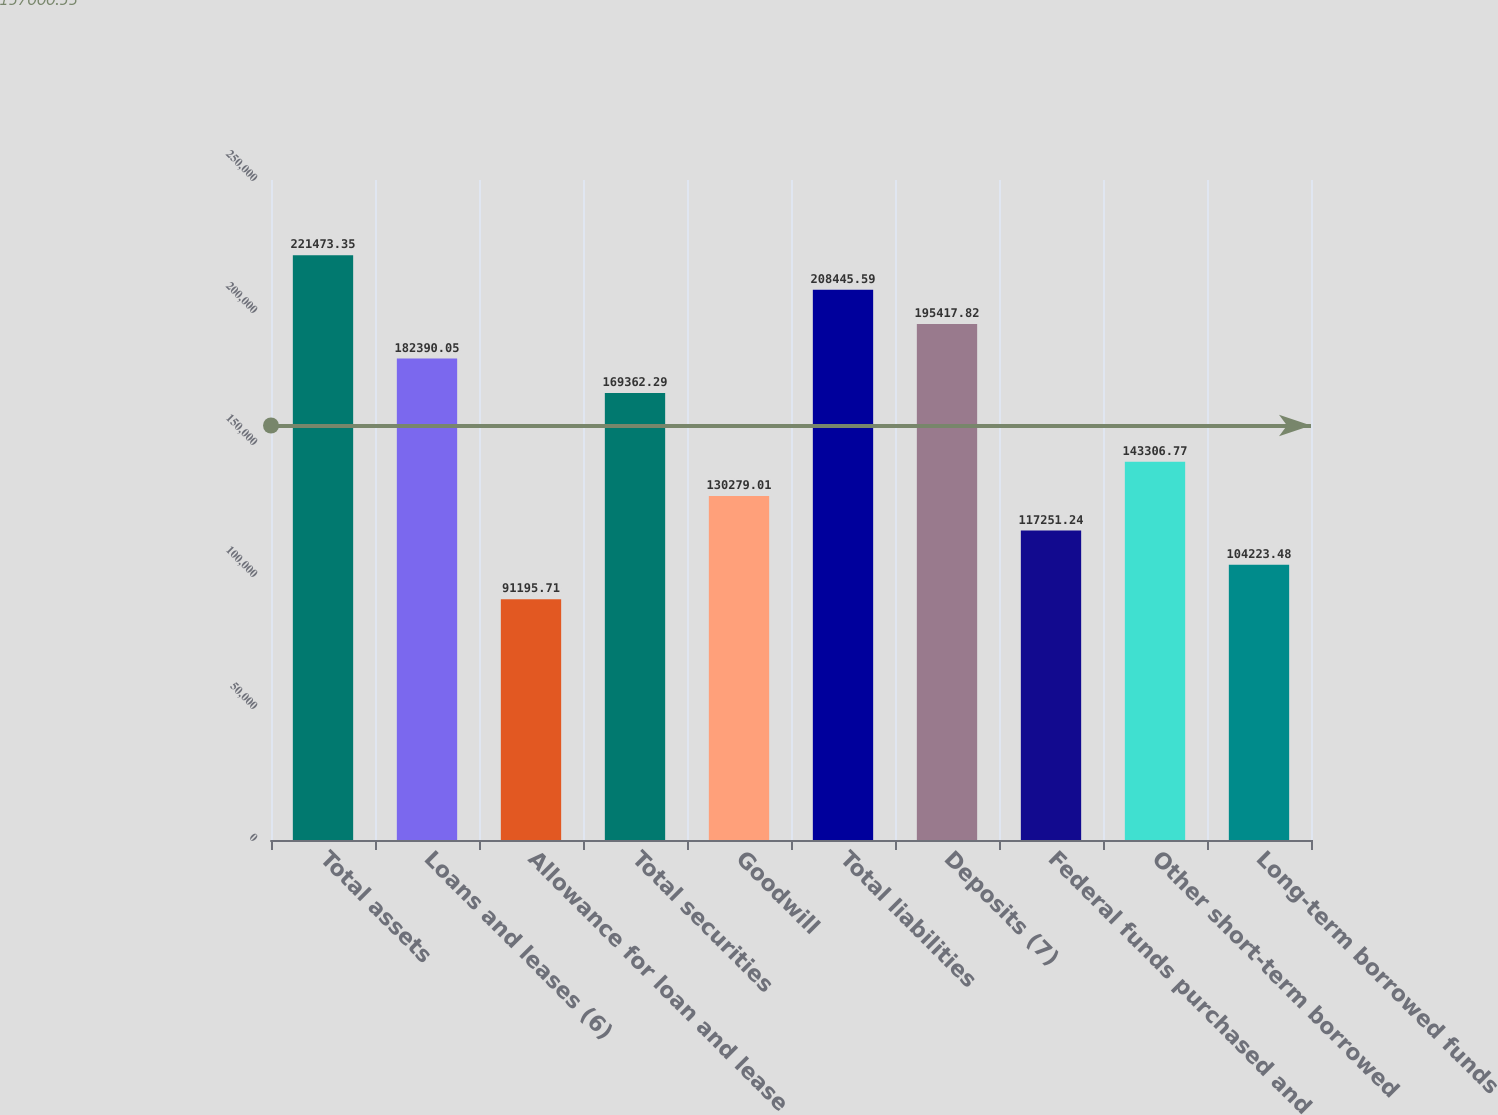<chart> <loc_0><loc_0><loc_500><loc_500><bar_chart><fcel>Total assets<fcel>Loans and leases (6)<fcel>Allowance for loan and lease<fcel>Total securities<fcel>Goodwill<fcel>Total liabilities<fcel>Deposits (7)<fcel>Federal funds purchased and<fcel>Other short-term borrowed<fcel>Long-term borrowed funds<nl><fcel>221473<fcel>182390<fcel>91195.7<fcel>169362<fcel>130279<fcel>208446<fcel>195418<fcel>117251<fcel>143307<fcel>104223<nl></chart> 